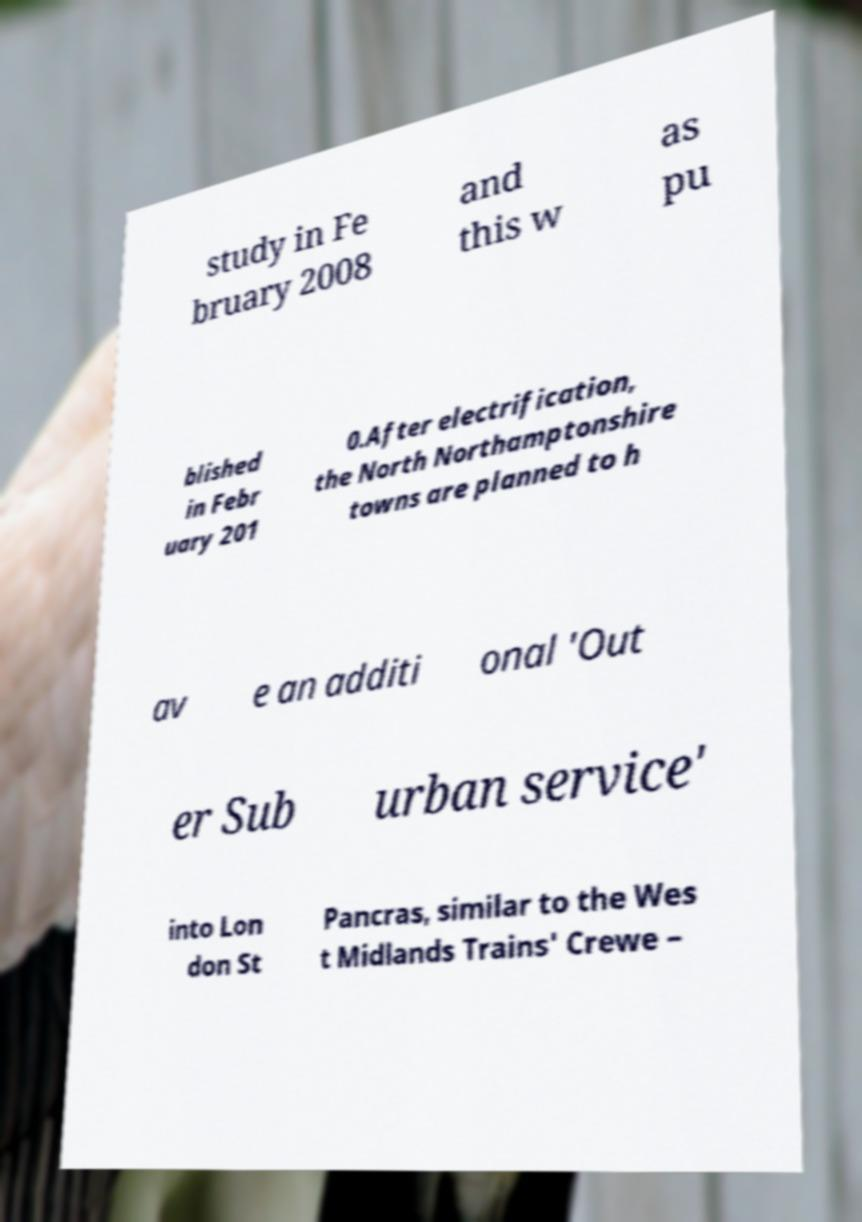Please identify and transcribe the text found in this image. study in Fe bruary 2008 and this w as pu blished in Febr uary 201 0.After electrification, the North Northamptonshire towns are planned to h av e an additi onal 'Out er Sub urban service' into Lon don St Pancras, similar to the Wes t Midlands Trains' Crewe – 